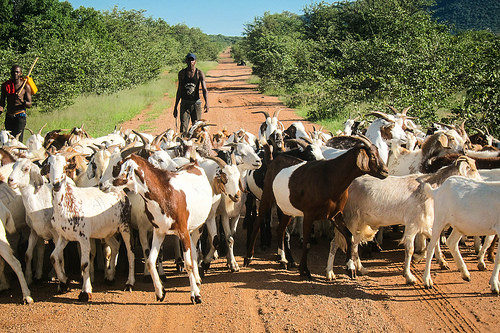<image>
Can you confirm if the man is above the goat? No. The man is not positioned above the goat. The vertical arrangement shows a different relationship. Where is the man in relation to the goat? Is it in front of the goat? No. The man is not in front of the goat. The spatial positioning shows a different relationship between these objects. Is the man in front of the goat? No. The man is not in front of the goat. The spatial positioning shows a different relationship between these objects. 